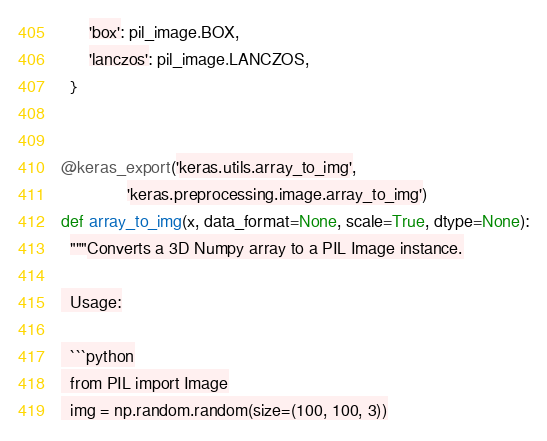<code> <loc_0><loc_0><loc_500><loc_500><_Python_>      'box': pil_image.BOX,
      'lanczos': pil_image.LANCZOS,
  }


@keras_export('keras.utils.array_to_img',
              'keras.preprocessing.image.array_to_img')
def array_to_img(x, data_format=None, scale=True, dtype=None):
  """Converts a 3D Numpy array to a PIL Image instance.

  Usage:

  ```python
  from PIL import Image
  img = np.random.random(size=(100, 100, 3))</code> 